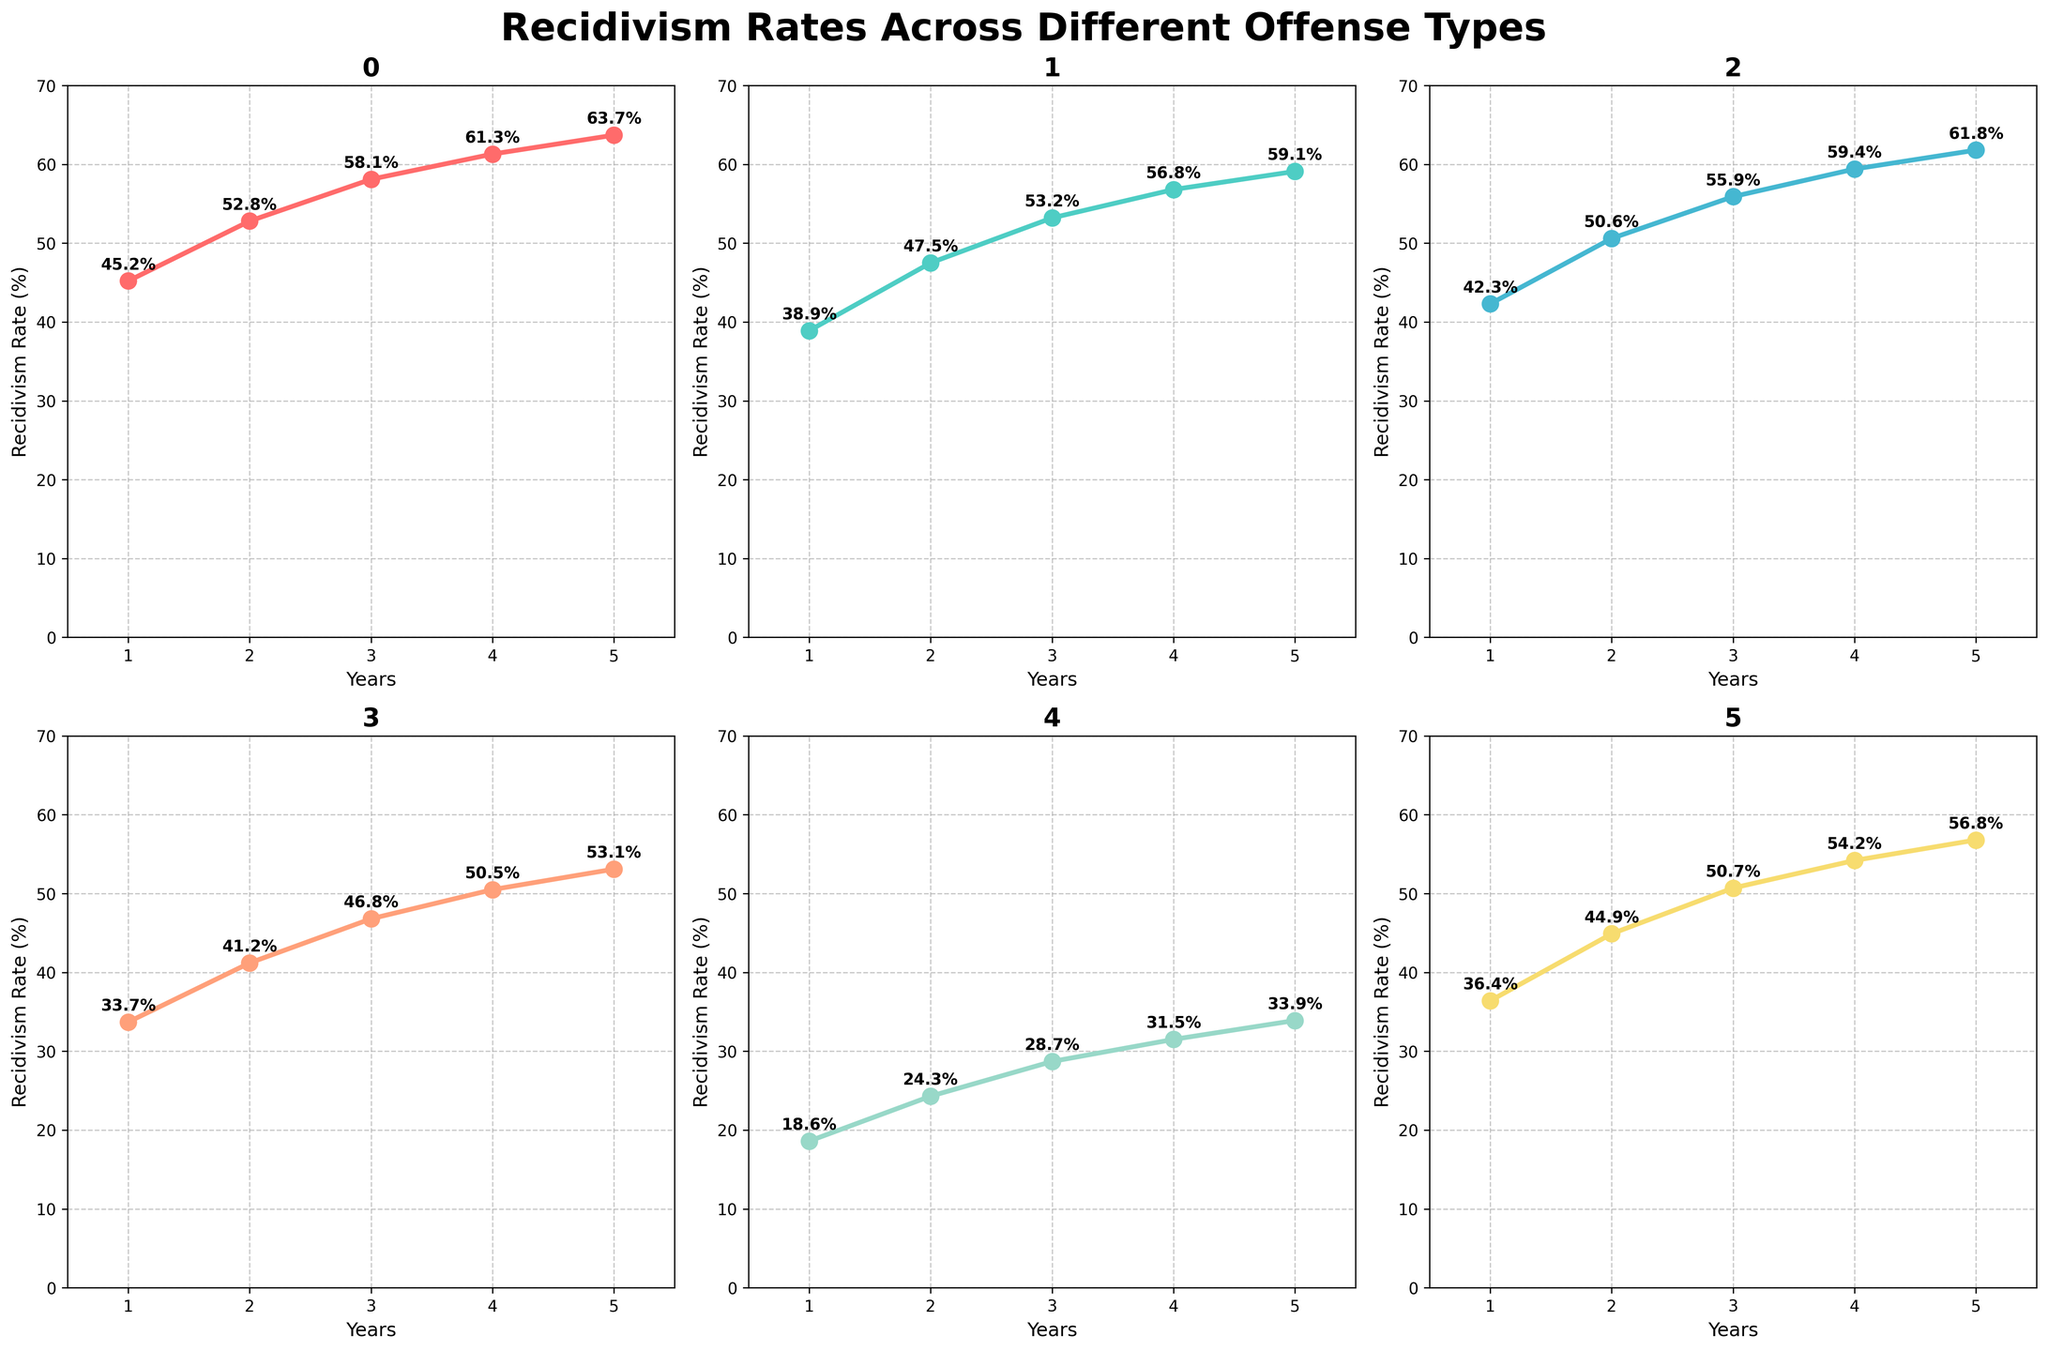What is the title of the figure? The title is usually located at the top of the figure, which in this case mentions the focus on recidivism rates and offense types.
Answer: Recidivism Rates Across Different Offense Types How many subplots are there? You can count the number of smaller individual charts within the main figure.
Answer: 6 Which offense type has the highest recidivism rate in Year 5? Look at the data points for Year 5 in each subplot and identify the highest value.
Answer: Violent Offenses What is the recidivism rate for White-Collar Crimes in Year 2? Check the subplot for White-Collar Crimes and look for the data point corresponding to Year 2.
Answer: 24.3% Which offense type shows the largest increase in recidivism rate from Year 1 to Year 5? Calculate the difference between the rates for each offense from Year 1 to Year 5 and find the largest value.
Answer: Property Crimes What is the average recidivism rate for Juvenile Offenses over 5 years? Add the recidivism rates for Juvenile Offenses from Year 1 to Year 5 and divide by 5.
Answer: 48.6% Which offense type has the lowest recidivism rate in Year 3? Check the data points for Year 3 in each subplot and identify the lowest value.
Answer: White-Collar Crimes Between which years does Public Order Offenses show the largest annual increase in recidivism rate? Calculate the difference between each pair of consecutive years for Public Order Offenses and identify the largest increase.
Answer: Year 1 to Year 2 What is the median recidivism rate for Drug-Related Offenses over the 5 years? List all 5 recidivism rates for Drug-Related Offenses and select the middle value when sorted in ascending order.
Answer: 55.9% By how many percentage points does the recidivism rate for Property Crimes increase from Year 3 to Year 4? Subtract the recidivism rate of Year 3 from Year 4 for Property Crimes.
Answer: 3.6% 